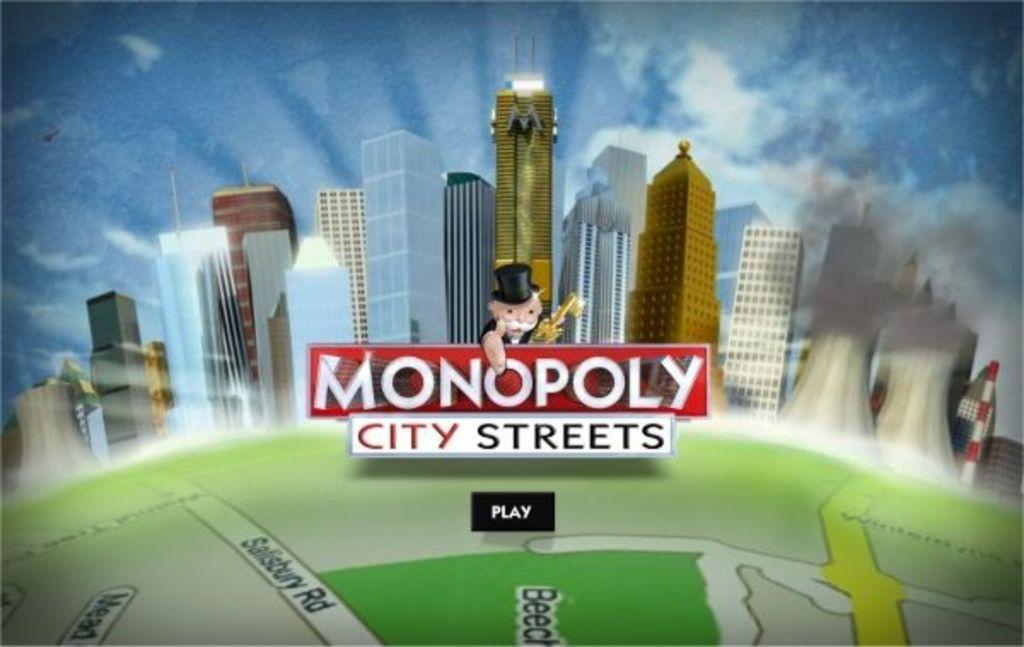What box game is that?
Provide a short and direct response. Monopoly. What is the bottom word on the button?
Make the answer very short. Play. 